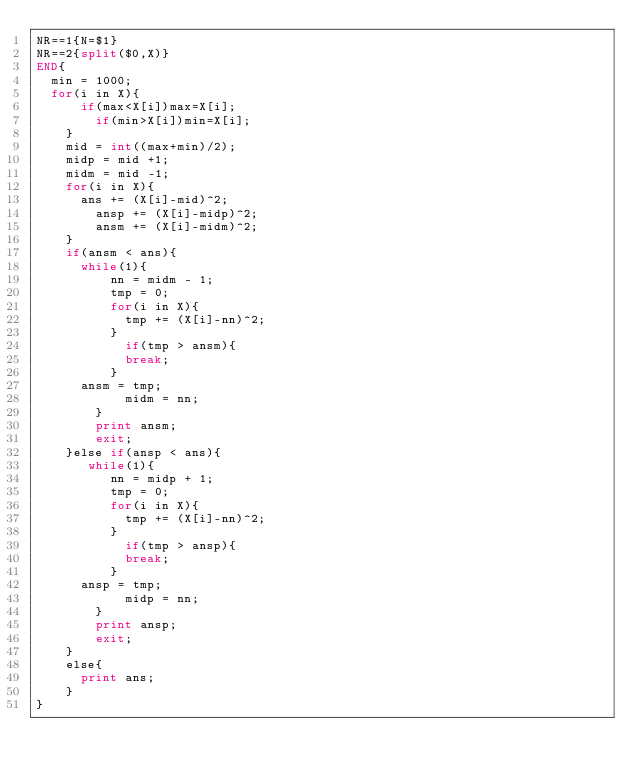Convert code to text. <code><loc_0><loc_0><loc_500><loc_500><_Awk_>NR==1{N=$1}
NR==2{split($0,X)}
END{
	min = 1000;
	for(i in X){
    	if(max<X[i])max=X[i];
        if(min>X[i])min=X[i];
    }
    mid = int((max+min)/2);
    midp = mid +1;
    midm = mid -1;
    for(i in X){
    	ans += (X[i]-mid)^2;
        ansp += (X[i]-midp)^2;
        ansm += (X[i]-midm)^2;
    }
    if(ansm < ans){
    	while(1){
        	nn = midm - 1;
        	tmp = 0;
        	for(i in X){
	        	tmp += (X[i]-nn)^2;
    	    }
            if(tmp > ansm){
        		break;
        	}
			ansm = tmp;
            midm = nn;
        }
        print ansm;
        exit;
    }else if(ansp < ans){
    	 while(1){
        	nn = midp + 1;
        	tmp = 0;
        	for(i in X){
	        	tmp += (X[i]-nn)^2;
    	    }
            if(tmp > ansp){
        		break;
        	}
			ansp = tmp;
            midp = nn;
        }
        print ansp;
        exit;
    }
    else{
    	print ans;
    }
}
</code> 